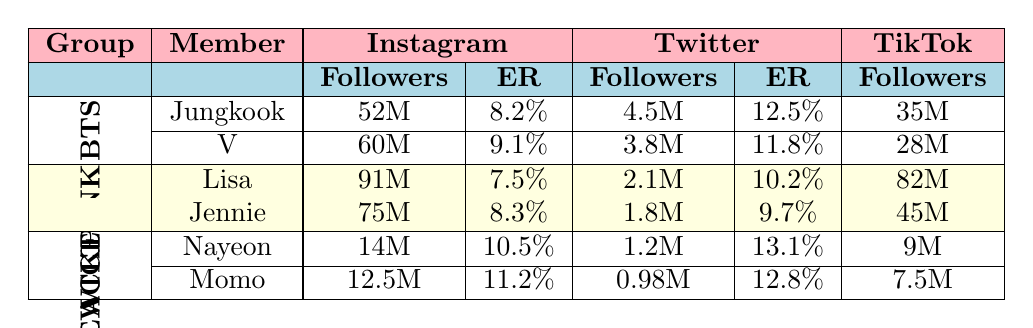What's the total follower count for Jungkook on all platforms? Jungkook has 52M followers on Instagram, 4.5M on Twitter, and 35M on TikTok. Adding these values gives: 52 + 4.5 + 35 = 91.5M followers.
Answer: 91.5M Which member of BLACKPINK has the highest engagement rate? Lisa has an engagement rate of 7.5% on Instagram, 10.2% on Twitter, and 13.8% on TikTok. Jennie's engagement rates are 8.3% on Instagram, 9.7% on Twitter, and 12.9% on TikTok. The highest engagement rate is 13.8% for Lisa on TikTok.
Answer: Lisa What is the average engagement rate for the members of TWICE? Nayeon's engagement rates are 10.5%, 13.1%, and 16.2%, while Momo's are 11.2%, 12.8%, and 15.9%. The average is calculated by summing both members' engagement rates and dividing by 6: (10.5 + 13.1 + 16.2 + 11.2 + 12.8 + 15.9) / 6 = 13.1%.
Answer: 13.1% True or False: V has more followers on Twitter than Jungkook. V has 3.8M followers on Twitter while Jungkook has 4.5M followers. Thus, it's false that V has more followers.
Answer: False Which K-pop group has the highest total follower count across all members on Instagram? BTS has 52M (Jungkook) + 60M (V) = 112M. BLACKPINK has 91M (Lisa) + 75M (Jennie) = 166M. TWICE has 14M (Nayeon) + 12.5M (Momo) = 26.5M. BLACKPINK has the highest count with 166M.
Answer: BLACKPINK What is the difference in follower count on TikTok between the member with the most and the member with the least in TWICE? Nayeon has 9M followers and Momo has 7.5M followers on TikTok. The difference is 9M - 7.5M = 1.5M.
Answer: 1.5M What is the sum of the followers for all members in BTS? The followers for BTS members are 52M (Jungkook) + 60M (V) = 112M.
Answer: 112M Who has the highest follower count on Instagram among all the members in the table? Lisa has the highest follower count on Instagram with 91M followers.
Answer: Lisa 